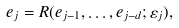Convert formula to latex. <formula><loc_0><loc_0><loc_500><loc_500>e _ { j } = R ( e _ { j - 1 } , \dots , e _ { j - d } ; \varepsilon _ { j } ) ,</formula> 